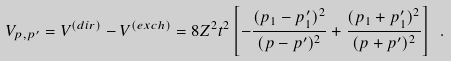<formula> <loc_0><loc_0><loc_500><loc_500>V _ { p , p ^ { \prime } } = V ^ { ( d i r ) } - V ^ { ( e x c h ) } = 8 Z ^ { 2 } t ^ { 2 } \left [ - \frac { ( p _ { 1 } - p ^ { \prime } _ { 1 } ) ^ { 2 } } { ( { p - p ^ { \prime } } ) ^ { 2 } } + \frac { ( p _ { 1 } + p ^ { \prime } _ { 1 } ) ^ { 2 } } { ( { p + p ^ { \prime } } ) ^ { 2 } } \right ] \ .</formula> 